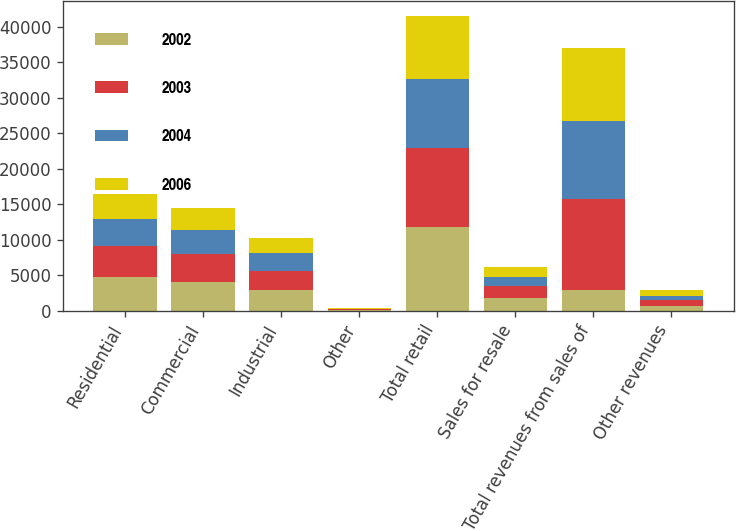Convert chart. <chart><loc_0><loc_0><loc_500><loc_500><stacked_bar_chart><ecel><fcel>Residential<fcel>Commercial<fcel>Industrial<fcel>Other<fcel>Total retail<fcel>Sales for resale<fcel>Total revenues from sales of<fcel>Other revenues<nl><fcel>2002<fcel>4716<fcel>4117<fcel>2866<fcel>102<fcel>11801<fcel>1822<fcel>2866<fcel>733<nl><fcel>2003<fcel>4376<fcel>3904<fcel>2785<fcel>100<fcel>11165<fcel>1667<fcel>12832<fcel>722<nl><fcel>2004<fcel>3848<fcel>3346<fcel>2446<fcel>92<fcel>9732<fcel>1341<fcel>11073<fcel>656<nl><fcel>2006<fcel>3565<fcel>3075<fcel>2146<fcel>89<fcel>8875<fcel>1358<fcel>10233<fcel>785<nl></chart> 